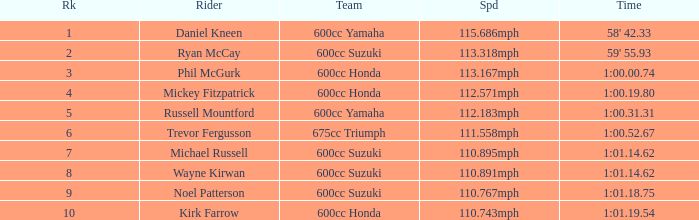How many ranks have 1:01.14.62 as the time, with michael russell as the rider? 1.0. Could you parse the entire table? {'header': ['Rk', 'Rider', 'Team', 'Spd', 'Time'], 'rows': [['1', 'Daniel Kneen', '600cc Yamaha', '115.686mph', "58' 42.33"], ['2', 'Ryan McCay', '600cc Suzuki', '113.318mph', "59' 55.93"], ['3', 'Phil McGurk', '600cc Honda', '113.167mph', '1:00.00.74'], ['4', 'Mickey Fitzpatrick', '600cc Honda', '112.571mph', '1:00.19.80'], ['5', 'Russell Mountford', '600cc Yamaha', '112.183mph', '1:00.31.31'], ['6', 'Trevor Fergusson', '675cc Triumph', '111.558mph', '1:00.52.67'], ['7', 'Michael Russell', '600cc Suzuki', '110.895mph', '1:01.14.62'], ['8', 'Wayne Kirwan', '600cc Suzuki', '110.891mph', '1:01.14.62'], ['9', 'Noel Patterson', '600cc Suzuki', '110.767mph', '1:01.18.75'], ['10', 'Kirk Farrow', '600cc Honda', '110.743mph', '1:01.19.54']]} 